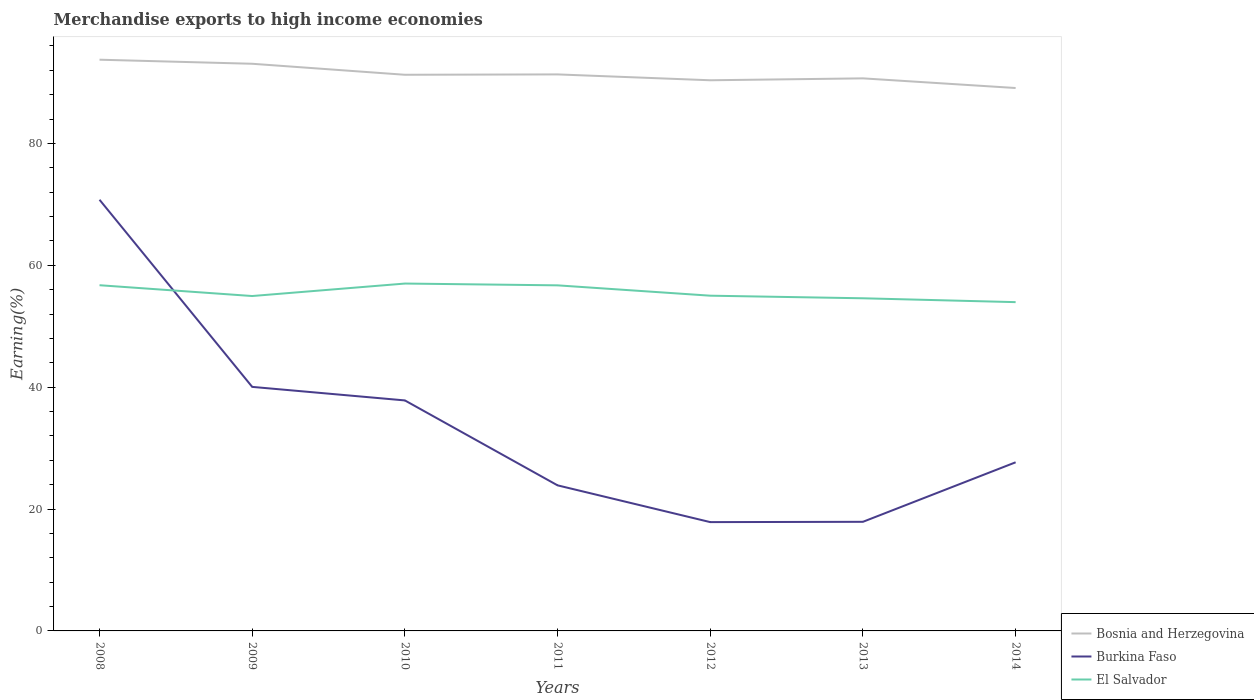Across all years, what is the maximum percentage of amount earned from merchandise exports in Burkina Faso?
Your answer should be compact. 17.86. In which year was the percentage of amount earned from merchandise exports in El Salvador maximum?
Offer a very short reply. 2014. What is the total percentage of amount earned from merchandise exports in Burkina Faso in the graph?
Make the answer very short. 46.87. What is the difference between the highest and the second highest percentage of amount earned from merchandise exports in Burkina Faso?
Keep it short and to the point. 52.9. How many lines are there?
Provide a short and direct response. 3. Are the values on the major ticks of Y-axis written in scientific E-notation?
Offer a very short reply. No. Does the graph contain any zero values?
Ensure brevity in your answer.  No. What is the title of the graph?
Provide a succinct answer. Merchandise exports to high income economies. Does "France" appear as one of the legend labels in the graph?
Offer a very short reply. No. What is the label or title of the Y-axis?
Give a very brief answer. Earning(%). What is the Earning(%) in Bosnia and Herzegovina in 2008?
Ensure brevity in your answer.  93.74. What is the Earning(%) in Burkina Faso in 2008?
Provide a succinct answer. 70.76. What is the Earning(%) in El Salvador in 2008?
Your answer should be compact. 56.73. What is the Earning(%) of Bosnia and Herzegovina in 2009?
Give a very brief answer. 93.07. What is the Earning(%) of Burkina Faso in 2009?
Provide a short and direct response. 40.05. What is the Earning(%) of El Salvador in 2009?
Provide a succinct answer. 54.96. What is the Earning(%) of Bosnia and Herzegovina in 2010?
Keep it short and to the point. 91.27. What is the Earning(%) of Burkina Faso in 2010?
Provide a succinct answer. 37.83. What is the Earning(%) in El Salvador in 2010?
Offer a very short reply. 57.01. What is the Earning(%) in Bosnia and Herzegovina in 2011?
Offer a very short reply. 91.33. What is the Earning(%) in Burkina Faso in 2011?
Your answer should be very brief. 23.89. What is the Earning(%) of El Salvador in 2011?
Make the answer very short. 56.71. What is the Earning(%) of Bosnia and Herzegovina in 2012?
Give a very brief answer. 90.37. What is the Earning(%) of Burkina Faso in 2012?
Offer a terse response. 17.86. What is the Earning(%) of El Salvador in 2012?
Your answer should be compact. 55.01. What is the Earning(%) in Bosnia and Herzegovina in 2013?
Give a very brief answer. 90.68. What is the Earning(%) of Burkina Faso in 2013?
Your answer should be very brief. 17.91. What is the Earning(%) in El Salvador in 2013?
Ensure brevity in your answer.  54.59. What is the Earning(%) of Bosnia and Herzegovina in 2014?
Offer a terse response. 89.1. What is the Earning(%) in Burkina Faso in 2014?
Ensure brevity in your answer.  27.67. What is the Earning(%) of El Salvador in 2014?
Give a very brief answer. 53.96. Across all years, what is the maximum Earning(%) in Bosnia and Herzegovina?
Give a very brief answer. 93.74. Across all years, what is the maximum Earning(%) of Burkina Faso?
Provide a short and direct response. 70.76. Across all years, what is the maximum Earning(%) of El Salvador?
Ensure brevity in your answer.  57.01. Across all years, what is the minimum Earning(%) of Bosnia and Herzegovina?
Give a very brief answer. 89.1. Across all years, what is the minimum Earning(%) of Burkina Faso?
Your answer should be very brief. 17.86. Across all years, what is the minimum Earning(%) of El Salvador?
Offer a very short reply. 53.96. What is the total Earning(%) in Bosnia and Herzegovina in the graph?
Make the answer very short. 639.56. What is the total Earning(%) of Burkina Faso in the graph?
Your answer should be compact. 235.96. What is the total Earning(%) in El Salvador in the graph?
Keep it short and to the point. 388.97. What is the difference between the Earning(%) of Bosnia and Herzegovina in 2008 and that in 2009?
Your answer should be compact. 0.67. What is the difference between the Earning(%) of Burkina Faso in 2008 and that in 2009?
Provide a short and direct response. 30.71. What is the difference between the Earning(%) of El Salvador in 2008 and that in 2009?
Give a very brief answer. 1.77. What is the difference between the Earning(%) in Bosnia and Herzegovina in 2008 and that in 2010?
Give a very brief answer. 2.47. What is the difference between the Earning(%) of Burkina Faso in 2008 and that in 2010?
Keep it short and to the point. 32.93. What is the difference between the Earning(%) of El Salvador in 2008 and that in 2010?
Give a very brief answer. -0.27. What is the difference between the Earning(%) of Bosnia and Herzegovina in 2008 and that in 2011?
Ensure brevity in your answer.  2.41. What is the difference between the Earning(%) of Burkina Faso in 2008 and that in 2011?
Provide a short and direct response. 46.87. What is the difference between the Earning(%) in El Salvador in 2008 and that in 2011?
Give a very brief answer. 0.02. What is the difference between the Earning(%) of Bosnia and Herzegovina in 2008 and that in 2012?
Ensure brevity in your answer.  3.37. What is the difference between the Earning(%) in Burkina Faso in 2008 and that in 2012?
Give a very brief answer. 52.9. What is the difference between the Earning(%) of El Salvador in 2008 and that in 2012?
Ensure brevity in your answer.  1.72. What is the difference between the Earning(%) in Bosnia and Herzegovina in 2008 and that in 2013?
Your answer should be very brief. 3.06. What is the difference between the Earning(%) in Burkina Faso in 2008 and that in 2013?
Offer a terse response. 52.85. What is the difference between the Earning(%) of El Salvador in 2008 and that in 2013?
Offer a very short reply. 2.14. What is the difference between the Earning(%) of Bosnia and Herzegovina in 2008 and that in 2014?
Offer a very short reply. 4.65. What is the difference between the Earning(%) of Burkina Faso in 2008 and that in 2014?
Give a very brief answer. 43.09. What is the difference between the Earning(%) in El Salvador in 2008 and that in 2014?
Offer a terse response. 2.78. What is the difference between the Earning(%) of Bosnia and Herzegovina in 2009 and that in 2010?
Offer a very short reply. 1.81. What is the difference between the Earning(%) of Burkina Faso in 2009 and that in 2010?
Give a very brief answer. 2.22. What is the difference between the Earning(%) in El Salvador in 2009 and that in 2010?
Give a very brief answer. -2.05. What is the difference between the Earning(%) in Bosnia and Herzegovina in 2009 and that in 2011?
Ensure brevity in your answer.  1.75. What is the difference between the Earning(%) in Burkina Faso in 2009 and that in 2011?
Give a very brief answer. 16.16. What is the difference between the Earning(%) of El Salvador in 2009 and that in 2011?
Your answer should be compact. -1.75. What is the difference between the Earning(%) in Bosnia and Herzegovina in 2009 and that in 2012?
Keep it short and to the point. 2.71. What is the difference between the Earning(%) of Burkina Faso in 2009 and that in 2012?
Provide a succinct answer. 22.19. What is the difference between the Earning(%) of El Salvador in 2009 and that in 2012?
Your response must be concise. -0.05. What is the difference between the Earning(%) in Bosnia and Herzegovina in 2009 and that in 2013?
Keep it short and to the point. 2.39. What is the difference between the Earning(%) of Burkina Faso in 2009 and that in 2013?
Your answer should be very brief. 22.14. What is the difference between the Earning(%) in El Salvador in 2009 and that in 2013?
Make the answer very short. 0.37. What is the difference between the Earning(%) of Bosnia and Herzegovina in 2009 and that in 2014?
Keep it short and to the point. 3.98. What is the difference between the Earning(%) of Burkina Faso in 2009 and that in 2014?
Provide a short and direct response. 12.38. What is the difference between the Earning(%) in El Salvador in 2009 and that in 2014?
Offer a terse response. 1. What is the difference between the Earning(%) of Bosnia and Herzegovina in 2010 and that in 2011?
Provide a short and direct response. -0.06. What is the difference between the Earning(%) of Burkina Faso in 2010 and that in 2011?
Provide a succinct answer. 13.94. What is the difference between the Earning(%) of El Salvador in 2010 and that in 2011?
Your answer should be compact. 0.29. What is the difference between the Earning(%) in Bosnia and Herzegovina in 2010 and that in 2012?
Your answer should be compact. 0.9. What is the difference between the Earning(%) in Burkina Faso in 2010 and that in 2012?
Keep it short and to the point. 19.97. What is the difference between the Earning(%) in El Salvador in 2010 and that in 2012?
Your answer should be very brief. 1.99. What is the difference between the Earning(%) in Bosnia and Herzegovina in 2010 and that in 2013?
Offer a very short reply. 0.59. What is the difference between the Earning(%) in Burkina Faso in 2010 and that in 2013?
Give a very brief answer. 19.92. What is the difference between the Earning(%) of El Salvador in 2010 and that in 2013?
Provide a succinct answer. 2.42. What is the difference between the Earning(%) in Bosnia and Herzegovina in 2010 and that in 2014?
Ensure brevity in your answer.  2.17. What is the difference between the Earning(%) in Burkina Faso in 2010 and that in 2014?
Keep it short and to the point. 10.15. What is the difference between the Earning(%) in El Salvador in 2010 and that in 2014?
Give a very brief answer. 3.05. What is the difference between the Earning(%) in Burkina Faso in 2011 and that in 2012?
Your answer should be compact. 6.03. What is the difference between the Earning(%) in El Salvador in 2011 and that in 2012?
Your response must be concise. 1.7. What is the difference between the Earning(%) of Bosnia and Herzegovina in 2011 and that in 2013?
Your response must be concise. 0.65. What is the difference between the Earning(%) of Burkina Faso in 2011 and that in 2013?
Your answer should be very brief. 5.98. What is the difference between the Earning(%) in El Salvador in 2011 and that in 2013?
Your answer should be very brief. 2.12. What is the difference between the Earning(%) in Bosnia and Herzegovina in 2011 and that in 2014?
Give a very brief answer. 2.23. What is the difference between the Earning(%) of Burkina Faso in 2011 and that in 2014?
Make the answer very short. -3.78. What is the difference between the Earning(%) of El Salvador in 2011 and that in 2014?
Provide a succinct answer. 2.76. What is the difference between the Earning(%) in Bosnia and Herzegovina in 2012 and that in 2013?
Offer a very short reply. -0.31. What is the difference between the Earning(%) in Burkina Faso in 2012 and that in 2013?
Provide a succinct answer. -0.05. What is the difference between the Earning(%) in El Salvador in 2012 and that in 2013?
Your response must be concise. 0.42. What is the difference between the Earning(%) in Bosnia and Herzegovina in 2012 and that in 2014?
Provide a succinct answer. 1.27. What is the difference between the Earning(%) of Burkina Faso in 2012 and that in 2014?
Your response must be concise. -9.82. What is the difference between the Earning(%) of El Salvador in 2012 and that in 2014?
Your answer should be very brief. 1.06. What is the difference between the Earning(%) of Bosnia and Herzegovina in 2013 and that in 2014?
Offer a very short reply. 1.59. What is the difference between the Earning(%) of Burkina Faso in 2013 and that in 2014?
Your answer should be very brief. -9.77. What is the difference between the Earning(%) in El Salvador in 2013 and that in 2014?
Offer a terse response. 0.63. What is the difference between the Earning(%) of Bosnia and Herzegovina in 2008 and the Earning(%) of Burkina Faso in 2009?
Ensure brevity in your answer.  53.69. What is the difference between the Earning(%) of Bosnia and Herzegovina in 2008 and the Earning(%) of El Salvador in 2009?
Make the answer very short. 38.78. What is the difference between the Earning(%) in Burkina Faso in 2008 and the Earning(%) in El Salvador in 2009?
Your answer should be very brief. 15.8. What is the difference between the Earning(%) in Bosnia and Herzegovina in 2008 and the Earning(%) in Burkina Faso in 2010?
Your answer should be compact. 55.92. What is the difference between the Earning(%) of Bosnia and Herzegovina in 2008 and the Earning(%) of El Salvador in 2010?
Offer a terse response. 36.74. What is the difference between the Earning(%) in Burkina Faso in 2008 and the Earning(%) in El Salvador in 2010?
Your answer should be compact. 13.75. What is the difference between the Earning(%) of Bosnia and Herzegovina in 2008 and the Earning(%) of Burkina Faso in 2011?
Your response must be concise. 69.85. What is the difference between the Earning(%) in Bosnia and Herzegovina in 2008 and the Earning(%) in El Salvador in 2011?
Provide a succinct answer. 37.03. What is the difference between the Earning(%) in Burkina Faso in 2008 and the Earning(%) in El Salvador in 2011?
Offer a terse response. 14.05. What is the difference between the Earning(%) in Bosnia and Herzegovina in 2008 and the Earning(%) in Burkina Faso in 2012?
Ensure brevity in your answer.  75.89. What is the difference between the Earning(%) in Bosnia and Herzegovina in 2008 and the Earning(%) in El Salvador in 2012?
Your response must be concise. 38.73. What is the difference between the Earning(%) in Burkina Faso in 2008 and the Earning(%) in El Salvador in 2012?
Your answer should be compact. 15.74. What is the difference between the Earning(%) of Bosnia and Herzegovina in 2008 and the Earning(%) of Burkina Faso in 2013?
Give a very brief answer. 75.84. What is the difference between the Earning(%) in Bosnia and Herzegovina in 2008 and the Earning(%) in El Salvador in 2013?
Your answer should be very brief. 39.15. What is the difference between the Earning(%) in Burkina Faso in 2008 and the Earning(%) in El Salvador in 2013?
Offer a terse response. 16.17. What is the difference between the Earning(%) in Bosnia and Herzegovina in 2008 and the Earning(%) in Burkina Faso in 2014?
Give a very brief answer. 66.07. What is the difference between the Earning(%) of Bosnia and Herzegovina in 2008 and the Earning(%) of El Salvador in 2014?
Your response must be concise. 39.79. What is the difference between the Earning(%) of Burkina Faso in 2008 and the Earning(%) of El Salvador in 2014?
Give a very brief answer. 16.8. What is the difference between the Earning(%) in Bosnia and Herzegovina in 2009 and the Earning(%) in Burkina Faso in 2010?
Provide a short and direct response. 55.25. What is the difference between the Earning(%) in Bosnia and Herzegovina in 2009 and the Earning(%) in El Salvador in 2010?
Ensure brevity in your answer.  36.07. What is the difference between the Earning(%) of Burkina Faso in 2009 and the Earning(%) of El Salvador in 2010?
Keep it short and to the point. -16.96. What is the difference between the Earning(%) in Bosnia and Herzegovina in 2009 and the Earning(%) in Burkina Faso in 2011?
Your answer should be very brief. 69.19. What is the difference between the Earning(%) of Bosnia and Herzegovina in 2009 and the Earning(%) of El Salvador in 2011?
Offer a very short reply. 36.36. What is the difference between the Earning(%) of Burkina Faso in 2009 and the Earning(%) of El Salvador in 2011?
Give a very brief answer. -16.66. What is the difference between the Earning(%) of Bosnia and Herzegovina in 2009 and the Earning(%) of Burkina Faso in 2012?
Your response must be concise. 75.22. What is the difference between the Earning(%) of Bosnia and Herzegovina in 2009 and the Earning(%) of El Salvador in 2012?
Provide a succinct answer. 38.06. What is the difference between the Earning(%) of Burkina Faso in 2009 and the Earning(%) of El Salvador in 2012?
Your response must be concise. -14.97. What is the difference between the Earning(%) of Bosnia and Herzegovina in 2009 and the Earning(%) of Burkina Faso in 2013?
Keep it short and to the point. 75.17. What is the difference between the Earning(%) of Bosnia and Herzegovina in 2009 and the Earning(%) of El Salvador in 2013?
Give a very brief answer. 38.49. What is the difference between the Earning(%) of Burkina Faso in 2009 and the Earning(%) of El Salvador in 2013?
Provide a succinct answer. -14.54. What is the difference between the Earning(%) of Bosnia and Herzegovina in 2009 and the Earning(%) of Burkina Faso in 2014?
Provide a succinct answer. 65.4. What is the difference between the Earning(%) in Bosnia and Herzegovina in 2009 and the Earning(%) in El Salvador in 2014?
Give a very brief answer. 39.12. What is the difference between the Earning(%) in Burkina Faso in 2009 and the Earning(%) in El Salvador in 2014?
Make the answer very short. -13.91. What is the difference between the Earning(%) of Bosnia and Herzegovina in 2010 and the Earning(%) of Burkina Faso in 2011?
Offer a very short reply. 67.38. What is the difference between the Earning(%) in Bosnia and Herzegovina in 2010 and the Earning(%) in El Salvador in 2011?
Your answer should be compact. 34.56. What is the difference between the Earning(%) of Burkina Faso in 2010 and the Earning(%) of El Salvador in 2011?
Your answer should be compact. -18.88. What is the difference between the Earning(%) in Bosnia and Herzegovina in 2010 and the Earning(%) in Burkina Faso in 2012?
Your answer should be very brief. 73.41. What is the difference between the Earning(%) in Bosnia and Herzegovina in 2010 and the Earning(%) in El Salvador in 2012?
Your answer should be compact. 36.26. What is the difference between the Earning(%) in Burkina Faso in 2010 and the Earning(%) in El Salvador in 2012?
Offer a very short reply. -17.19. What is the difference between the Earning(%) in Bosnia and Herzegovina in 2010 and the Earning(%) in Burkina Faso in 2013?
Your answer should be very brief. 73.36. What is the difference between the Earning(%) in Bosnia and Herzegovina in 2010 and the Earning(%) in El Salvador in 2013?
Give a very brief answer. 36.68. What is the difference between the Earning(%) in Burkina Faso in 2010 and the Earning(%) in El Salvador in 2013?
Provide a succinct answer. -16.76. What is the difference between the Earning(%) of Bosnia and Herzegovina in 2010 and the Earning(%) of Burkina Faso in 2014?
Make the answer very short. 63.6. What is the difference between the Earning(%) in Bosnia and Herzegovina in 2010 and the Earning(%) in El Salvador in 2014?
Offer a very short reply. 37.31. What is the difference between the Earning(%) of Burkina Faso in 2010 and the Earning(%) of El Salvador in 2014?
Your response must be concise. -16.13. What is the difference between the Earning(%) of Bosnia and Herzegovina in 2011 and the Earning(%) of Burkina Faso in 2012?
Offer a terse response. 73.47. What is the difference between the Earning(%) of Bosnia and Herzegovina in 2011 and the Earning(%) of El Salvador in 2012?
Provide a short and direct response. 36.31. What is the difference between the Earning(%) of Burkina Faso in 2011 and the Earning(%) of El Salvador in 2012?
Provide a succinct answer. -31.12. What is the difference between the Earning(%) in Bosnia and Herzegovina in 2011 and the Earning(%) in Burkina Faso in 2013?
Keep it short and to the point. 73.42. What is the difference between the Earning(%) in Bosnia and Herzegovina in 2011 and the Earning(%) in El Salvador in 2013?
Your answer should be very brief. 36.74. What is the difference between the Earning(%) of Burkina Faso in 2011 and the Earning(%) of El Salvador in 2013?
Offer a very short reply. -30.7. What is the difference between the Earning(%) of Bosnia and Herzegovina in 2011 and the Earning(%) of Burkina Faso in 2014?
Keep it short and to the point. 63.66. What is the difference between the Earning(%) in Bosnia and Herzegovina in 2011 and the Earning(%) in El Salvador in 2014?
Offer a terse response. 37.37. What is the difference between the Earning(%) of Burkina Faso in 2011 and the Earning(%) of El Salvador in 2014?
Keep it short and to the point. -30.07. What is the difference between the Earning(%) in Bosnia and Herzegovina in 2012 and the Earning(%) in Burkina Faso in 2013?
Keep it short and to the point. 72.46. What is the difference between the Earning(%) in Bosnia and Herzegovina in 2012 and the Earning(%) in El Salvador in 2013?
Offer a very short reply. 35.78. What is the difference between the Earning(%) in Burkina Faso in 2012 and the Earning(%) in El Salvador in 2013?
Give a very brief answer. -36.73. What is the difference between the Earning(%) in Bosnia and Herzegovina in 2012 and the Earning(%) in Burkina Faso in 2014?
Offer a terse response. 62.7. What is the difference between the Earning(%) in Bosnia and Herzegovina in 2012 and the Earning(%) in El Salvador in 2014?
Offer a terse response. 36.41. What is the difference between the Earning(%) in Burkina Faso in 2012 and the Earning(%) in El Salvador in 2014?
Your answer should be compact. -36.1. What is the difference between the Earning(%) of Bosnia and Herzegovina in 2013 and the Earning(%) of Burkina Faso in 2014?
Your response must be concise. 63.01. What is the difference between the Earning(%) in Bosnia and Herzegovina in 2013 and the Earning(%) in El Salvador in 2014?
Offer a very short reply. 36.72. What is the difference between the Earning(%) in Burkina Faso in 2013 and the Earning(%) in El Salvador in 2014?
Your answer should be compact. -36.05. What is the average Earning(%) in Bosnia and Herzegovina per year?
Make the answer very short. 91.37. What is the average Earning(%) of Burkina Faso per year?
Your response must be concise. 33.71. What is the average Earning(%) in El Salvador per year?
Keep it short and to the point. 55.57. In the year 2008, what is the difference between the Earning(%) of Bosnia and Herzegovina and Earning(%) of Burkina Faso?
Give a very brief answer. 22.98. In the year 2008, what is the difference between the Earning(%) in Bosnia and Herzegovina and Earning(%) in El Salvador?
Ensure brevity in your answer.  37.01. In the year 2008, what is the difference between the Earning(%) in Burkina Faso and Earning(%) in El Salvador?
Provide a succinct answer. 14.03. In the year 2009, what is the difference between the Earning(%) in Bosnia and Herzegovina and Earning(%) in Burkina Faso?
Offer a very short reply. 53.03. In the year 2009, what is the difference between the Earning(%) of Bosnia and Herzegovina and Earning(%) of El Salvador?
Give a very brief answer. 38.12. In the year 2009, what is the difference between the Earning(%) in Burkina Faso and Earning(%) in El Salvador?
Your answer should be very brief. -14.91. In the year 2010, what is the difference between the Earning(%) of Bosnia and Herzegovina and Earning(%) of Burkina Faso?
Provide a short and direct response. 53.44. In the year 2010, what is the difference between the Earning(%) in Bosnia and Herzegovina and Earning(%) in El Salvador?
Ensure brevity in your answer.  34.26. In the year 2010, what is the difference between the Earning(%) in Burkina Faso and Earning(%) in El Salvador?
Your answer should be very brief. -19.18. In the year 2011, what is the difference between the Earning(%) of Bosnia and Herzegovina and Earning(%) of Burkina Faso?
Your answer should be very brief. 67.44. In the year 2011, what is the difference between the Earning(%) in Bosnia and Herzegovina and Earning(%) in El Salvador?
Your response must be concise. 34.62. In the year 2011, what is the difference between the Earning(%) in Burkina Faso and Earning(%) in El Salvador?
Offer a very short reply. -32.82. In the year 2012, what is the difference between the Earning(%) of Bosnia and Herzegovina and Earning(%) of Burkina Faso?
Ensure brevity in your answer.  72.51. In the year 2012, what is the difference between the Earning(%) of Bosnia and Herzegovina and Earning(%) of El Salvador?
Ensure brevity in your answer.  35.35. In the year 2012, what is the difference between the Earning(%) in Burkina Faso and Earning(%) in El Salvador?
Offer a very short reply. -37.16. In the year 2013, what is the difference between the Earning(%) of Bosnia and Herzegovina and Earning(%) of Burkina Faso?
Keep it short and to the point. 72.77. In the year 2013, what is the difference between the Earning(%) of Bosnia and Herzegovina and Earning(%) of El Salvador?
Offer a terse response. 36.09. In the year 2013, what is the difference between the Earning(%) in Burkina Faso and Earning(%) in El Salvador?
Offer a very short reply. -36.68. In the year 2014, what is the difference between the Earning(%) in Bosnia and Herzegovina and Earning(%) in Burkina Faso?
Keep it short and to the point. 61.42. In the year 2014, what is the difference between the Earning(%) of Bosnia and Herzegovina and Earning(%) of El Salvador?
Provide a succinct answer. 35.14. In the year 2014, what is the difference between the Earning(%) in Burkina Faso and Earning(%) in El Salvador?
Provide a succinct answer. -26.28. What is the ratio of the Earning(%) of Burkina Faso in 2008 to that in 2009?
Provide a succinct answer. 1.77. What is the ratio of the Earning(%) of El Salvador in 2008 to that in 2009?
Offer a terse response. 1.03. What is the ratio of the Earning(%) of Bosnia and Herzegovina in 2008 to that in 2010?
Your answer should be compact. 1.03. What is the ratio of the Earning(%) in Burkina Faso in 2008 to that in 2010?
Give a very brief answer. 1.87. What is the ratio of the Earning(%) of Bosnia and Herzegovina in 2008 to that in 2011?
Offer a very short reply. 1.03. What is the ratio of the Earning(%) in Burkina Faso in 2008 to that in 2011?
Offer a terse response. 2.96. What is the ratio of the Earning(%) of Bosnia and Herzegovina in 2008 to that in 2012?
Your answer should be compact. 1.04. What is the ratio of the Earning(%) of Burkina Faso in 2008 to that in 2012?
Provide a short and direct response. 3.96. What is the ratio of the Earning(%) in El Salvador in 2008 to that in 2012?
Provide a short and direct response. 1.03. What is the ratio of the Earning(%) in Bosnia and Herzegovina in 2008 to that in 2013?
Give a very brief answer. 1.03. What is the ratio of the Earning(%) of Burkina Faso in 2008 to that in 2013?
Your response must be concise. 3.95. What is the ratio of the Earning(%) of El Salvador in 2008 to that in 2013?
Your answer should be compact. 1.04. What is the ratio of the Earning(%) of Bosnia and Herzegovina in 2008 to that in 2014?
Give a very brief answer. 1.05. What is the ratio of the Earning(%) in Burkina Faso in 2008 to that in 2014?
Keep it short and to the point. 2.56. What is the ratio of the Earning(%) in El Salvador in 2008 to that in 2014?
Provide a succinct answer. 1.05. What is the ratio of the Earning(%) in Bosnia and Herzegovina in 2009 to that in 2010?
Offer a very short reply. 1.02. What is the ratio of the Earning(%) of Burkina Faso in 2009 to that in 2010?
Give a very brief answer. 1.06. What is the ratio of the Earning(%) of El Salvador in 2009 to that in 2010?
Provide a short and direct response. 0.96. What is the ratio of the Earning(%) of Bosnia and Herzegovina in 2009 to that in 2011?
Provide a succinct answer. 1.02. What is the ratio of the Earning(%) of Burkina Faso in 2009 to that in 2011?
Your response must be concise. 1.68. What is the ratio of the Earning(%) in El Salvador in 2009 to that in 2011?
Provide a succinct answer. 0.97. What is the ratio of the Earning(%) in Bosnia and Herzegovina in 2009 to that in 2012?
Ensure brevity in your answer.  1.03. What is the ratio of the Earning(%) in Burkina Faso in 2009 to that in 2012?
Ensure brevity in your answer.  2.24. What is the ratio of the Earning(%) in Bosnia and Herzegovina in 2009 to that in 2013?
Your answer should be very brief. 1.03. What is the ratio of the Earning(%) of Burkina Faso in 2009 to that in 2013?
Your answer should be compact. 2.24. What is the ratio of the Earning(%) of El Salvador in 2009 to that in 2013?
Make the answer very short. 1.01. What is the ratio of the Earning(%) in Bosnia and Herzegovina in 2009 to that in 2014?
Ensure brevity in your answer.  1.04. What is the ratio of the Earning(%) of Burkina Faso in 2009 to that in 2014?
Your response must be concise. 1.45. What is the ratio of the Earning(%) in El Salvador in 2009 to that in 2014?
Offer a very short reply. 1.02. What is the ratio of the Earning(%) in Bosnia and Herzegovina in 2010 to that in 2011?
Your answer should be compact. 1. What is the ratio of the Earning(%) of Burkina Faso in 2010 to that in 2011?
Your answer should be very brief. 1.58. What is the ratio of the Earning(%) of Burkina Faso in 2010 to that in 2012?
Your answer should be compact. 2.12. What is the ratio of the Earning(%) of El Salvador in 2010 to that in 2012?
Provide a short and direct response. 1.04. What is the ratio of the Earning(%) in Burkina Faso in 2010 to that in 2013?
Your answer should be very brief. 2.11. What is the ratio of the Earning(%) of El Salvador in 2010 to that in 2013?
Your answer should be very brief. 1.04. What is the ratio of the Earning(%) of Bosnia and Herzegovina in 2010 to that in 2014?
Keep it short and to the point. 1.02. What is the ratio of the Earning(%) in Burkina Faso in 2010 to that in 2014?
Keep it short and to the point. 1.37. What is the ratio of the Earning(%) of El Salvador in 2010 to that in 2014?
Your answer should be very brief. 1.06. What is the ratio of the Earning(%) of Bosnia and Herzegovina in 2011 to that in 2012?
Offer a terse response. 1.01. What is the ratio of the Earning(%) of Burkina Faso in 2011 to that in 2012?
Your answer should be compact. 1.34. What is the ratio of the Earning(%) in El Salvador in 2011 to that in 2012?
Provide a succinct answer. 1.03. What is the ratio of the Earning(%) in Bosnia and Herzegovina in 2011 to that in 2013?
Offer a terse response. 1.01. What is the ratio of the Earning(%) of Burkina Faso in 2011 to that in 2013?
Your answer should be very brief. 1.33. What is the ratio of the Earning(%) in El Salvador in 2011 to that in 2013?
Offer a terse response. 1.04. What is the ratio of the Earning(%) in Bosnia and Herzegovina in 2011 to that in 2014?
Ensure brevity in your answer.  1.03. What is the ratio of the Earning(%) of Burkina Faso in 2011 to that in 2014?
Keep it short and to the point. 0.86. What is the ratio of the Earning(%) of El Salvador in 2011 to that in 2014?
Your response must be concise. 1.05. What is the ratio of the Earning(%) of Burkina Faso in 2012 to that in 2013?
Offer a very short reply. 1. What is the ratio of the Earning(%) in Bosnia and Herzegovina in 2012 to that in 2014?
Your answer should be very brief. 1.01. What is the ratio of the Earning(%) in Burkina Faso in 2012 to that in 2014?
Give a very brief answer. 0.65. What is the ratio of the Earning(%) of El Salvador in 2012 to that in 2014?
Your answer should be very brief. 1.02. What is the ratio of the Earning(%) in Bosnia and Herzegovina in 2013 to that in 2014?
Provide a short and direct response. 1.02. What is the ratio of the Earning(%) of Burkina Faso in 2013 to that in 2014?
Make the answer very short. 0.65. What is the ratio of the Earning(%) in El Salvador in 2013 to that in 2014?
Give a very brief answer. 1.01. What is the difference between the highest and the second highest Earning(%) of Bosnia and Herzegovina?
Keep it short and to the point. 0.67. What is the difference between the highest and the second highest Earning(%) of Burkina Faso?
Keep it short and to the point. 30.71. What is the difference between the highest and the second highest Earning(%) of El Salvador?
Your answer should be compact. 0.27. What is the difference between the highest and the lowest Earning(%) in Bosnia and Herzegovina?
Make the answer very short. 4.65. What is the difference between the highest and the lowest Earning(%) of Burkina Faso?
Ensure brevity in your answer.  52.9. What is the difference between the highest and the lowest Earning(%) in El Salvador?
Offer a very short reply. 3.05. 